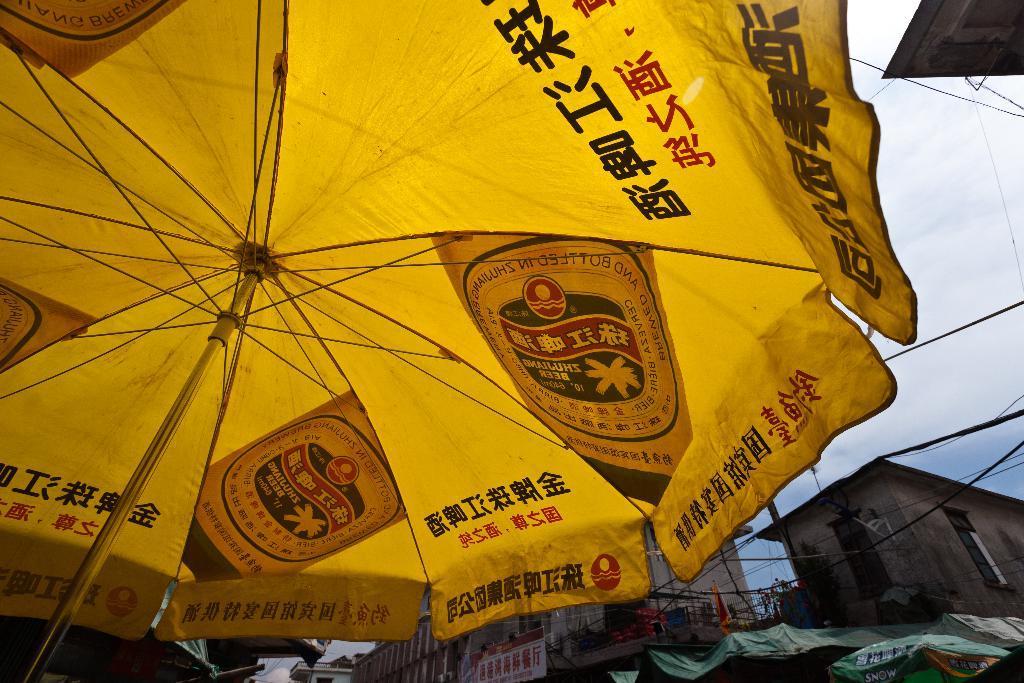Could you give a brief overview of what you see in this image? We can see umbrella and we can see buildings,wall,wires,banner and sky with clouds. 